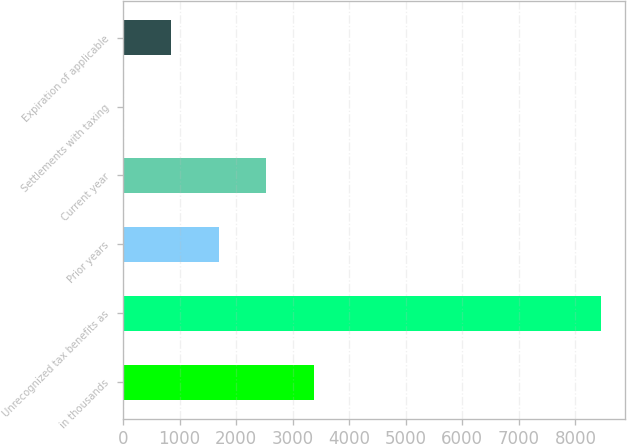Convert chart. <chart><loc_0><loc_0><loc_500><loc_500><bar_chart><fcel>in thousands<fcel>Unrecognized tax benefits as<fcel>Prior years<fcel>Current year<fcel>Settlements with taxing<fcel>Expiration of applicable<nl><fcel>3379.6<fcel>8447<fcel>1690.48<fcel>2535.04<fcel>1.36<fcel>845.92<nl></chart> 